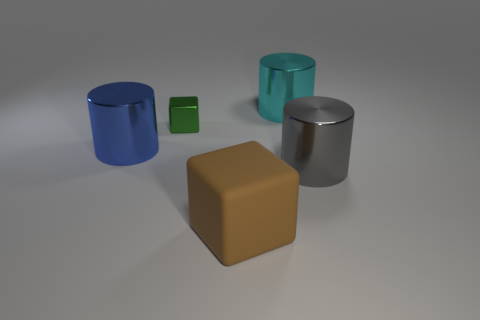The object in front of the cylinder in front of the large cylinder that is on the left side of the matte object is what color?
Provide a short and direct response. Brown. What number of objects are either blocks that are on the right side of the tiny metallic cube or matte things?
Your answer should be very brief. 1. There is a cyan thing that is the same size as the blue cylinder; what is its material?
Your answer should be very brief. Metal. The green cube that is left of the cube that is in front of the large shiny object that is on the left side of the small metal object is made of what material?
Make the answer very short. Metal. The small shiny thing has what color?
Provide a short and direct response. Green. How many big things are either cyan shiny cylinders or brown matte things?
Provide a short and direct response. 2. Is the thing right of the cyan shiny cylinder made of the same material as the object that is behind the tiny cube?
Give a very brief answer. Yes. Is there a large gray cylinder?
Your response must be concise. Yes. Are there more gray metallic cylinders to the left of the blue shiny cylinder than big cyan metal objects that are left of the cyan cylinder?
Your answer should be compact. No. What material is the other small object that is the same shape as the brown rubber object?
Offer a terse response. Metal. 